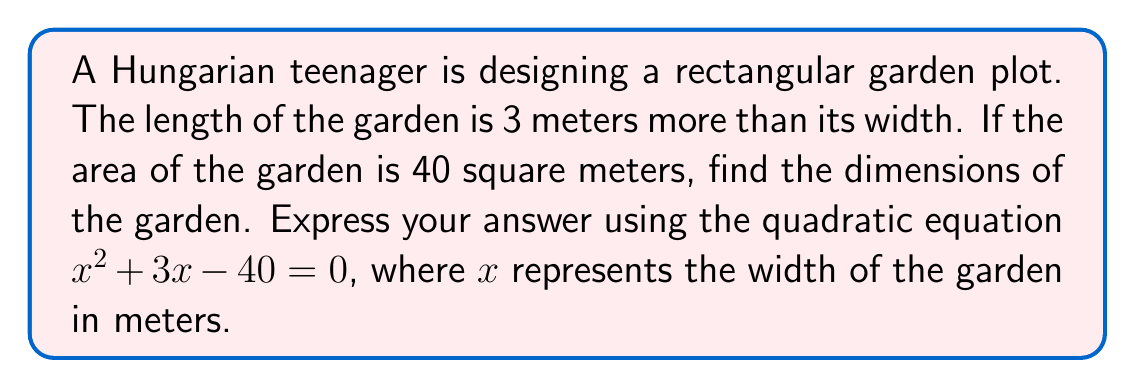Give your solution to this math problem. Let's approach this step-by-step:

1) First, we need to factor the quadratic expression $x^2 + 3x - 40 = 0$.

2) We can use the ac-method for factoring:
   a) Multiply a and c: $1 \cdot (-40) = -40$
   b) Find two numbers that multiply to give -40 and add to give 3: 8 and -5
   c) Rewrite the middle term: $x^2 + 8x - 5x - 40 = 0$
   d) Group the terms: $(x^2 + 8x) + (-5x - 40) = 0$
   e) Factor out common factors: $x(x + 8) - 5(x + 8) = 0$
   f) Factor out $(x + 8)$: $(x + 8)(x - 5) = 0$

3) Now that we've factored the expression, we can find the roots by setting each factor to zero:

   $x + 8 = 0$ or $x - 5 = 0$
   $x = -8$   or $x = 5$

4) Since we're dealing with physical dimensions, we can discard the negative solution. Therefore, the width of the garden is 5 meters.

5) The length is 3 meters more than the width, so it's 8 meters.

6) We can verify: $5 \cdot 8 = 40$ square meters, which matches the given area.
Answer: The dimensions of the garden are 5 meters wide and 8 meters long. The roots of the quadratic equation $x^2 + 3x - 40 = 0$ are $x = 5$ and $x = -8$. 